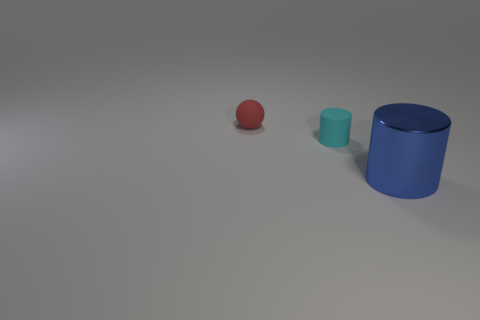There is a object that is in front of the small red object and behind the large metal cylinder; what material is it?
Your answer should be very brief. Rubber. Are there fewer large blue things than gray metal spheres?
Your answer should be compact. No. There is a cylinder that is in front of the small thing that is on the right side of the small ball; what size is it?
Provide a succinct answer. Large. What is the shape of the object that is on the left side of the cylinder that is left of the big blue metallic cylinder that is in front of the small red ball?
Provide a short and direct response. Sphere. There is a tiny sphere that is the same material as the small cyan object; what color is it?
Give a very brief answer. Red. The small matte object to the left of the tiny object right of the rubber thing on the left side of the cyan cylinder is what color?
Offer a very short reply. Red. How many spheres are blue objects or cyan objects?
Give a very brief answer. 0. There is a big thing; is it the same color as the cylinder that is behind the big blue metal cylinder?
Offer a very short reply. No. The rubber sphere has what color?
Your response must be concise. Red. What number of objects are either small green objects or small cylinders?
Ensure brevity in your answer.  1. 